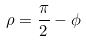Convert formula to latex. <formula><loc_0><loc_0><loc_500><loc_500>\rho = \frac { \pi } { 2 } - \phi</formula> 